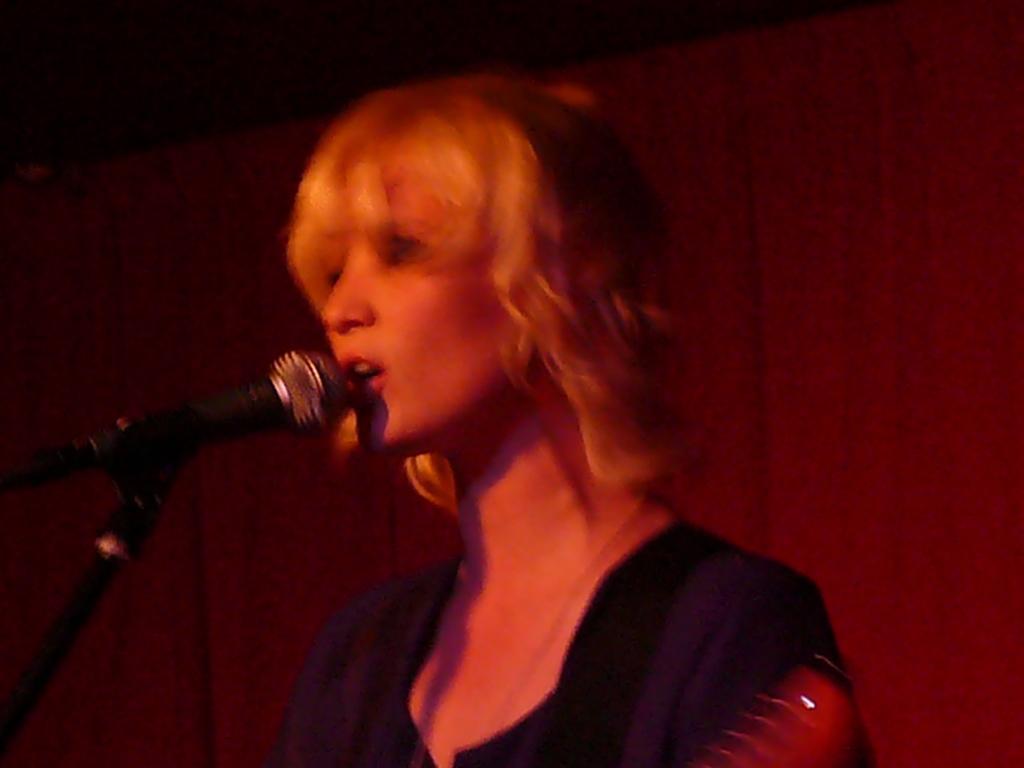Can you describe this image briefly? As we can see in the image there is a wall, light, mic and a woman wearing black color dress. 